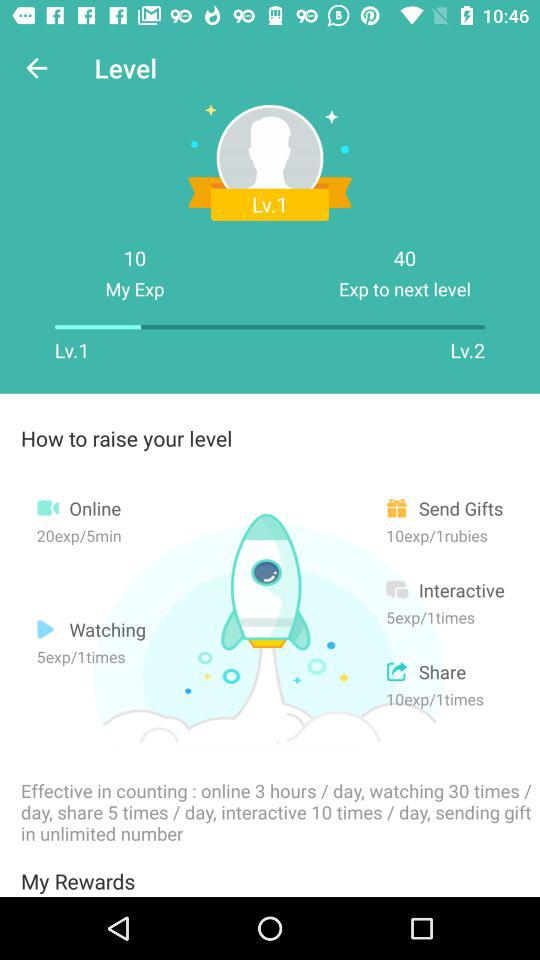How many gifts can we send? You can send unlimited gifts. 